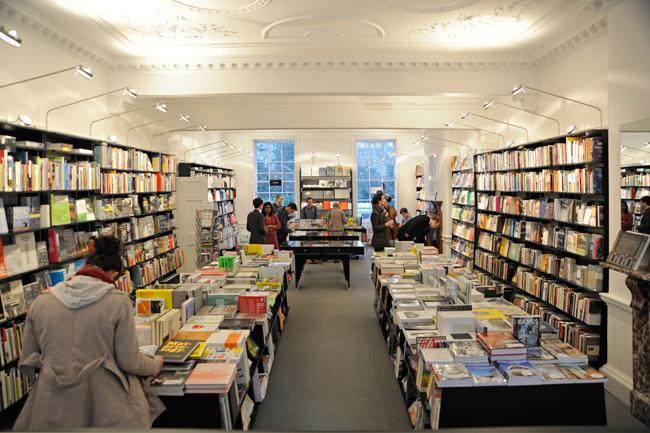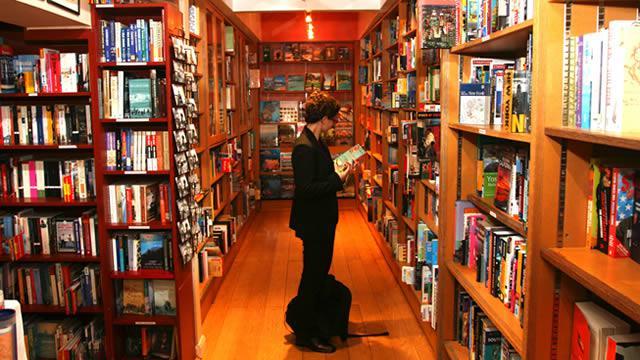The first image is the image on the left, the second image is the image on the right. Assess this claim about the two images: "There are three or more people shopping for books in the left image.". Correct or not? Answer yes or no. Yes. The first image is the image on the left, the second image is the image on the right. Examine the images to the left and right. Is the description "A wall in one image has windows that show a glimpse of outside the bookshop." accurate? Answer yes or no. Yes. 